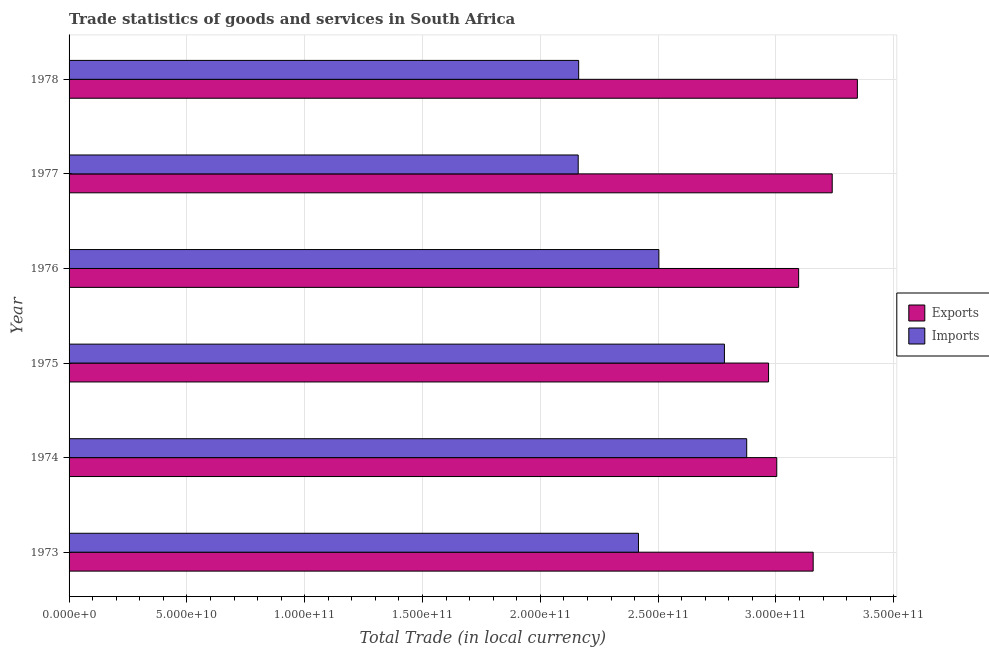How many groups of bars are there?
Offer a very short reply. 6. Are the number of bars per tick equal to the number of legend labels?
Provide a short and direct response. Yes. How many bars are there on the 3rd tick from the top?
Give a very brief answer. 2. How many bars are there on the 4th tick from the bottom?
Ensure brevity in your answer.  2. What is the label of the 4th group of bars from the top?
Make the answer very short. 1975. In how many cases, is the number of bars for a given year not equal to the number of legend labels?
Offer a very short reply. 0. What is the imports of goods and services in 1976?
Your answer should be very brief. 2.50e+11. Across all years, what is the maximum export of goods and services?
Your answer should be compact. 3.35e+11. Across all years, what is the minimum export of goods and services?
Offer a very short reply. 2.97e+11. In which year was the export of goods and services maximum?
Give a very brief answer. 1978. What is the total export of goods and services in the graph?
Ensure brevity in your answer.  1.88e+12. What is the difference between the imports of goods and services in 1975 and that in 1978?
Offer a very short reply. 6.19e+1. What is the difference between the imports of goods and services in 1974 and the export of goods and services in 1976?
Provide a short and direct response. -2.20e+1. What is the average imports of goods and services per year?
Your response must be concise. 2.48e+11. In the year 1975, what is the difference between the export of goods and services and imports of goods and services?
Provide a short and direct response. 1.87e+1. What is the ratio of the imports of goods and services in 1976 to that in 1978?
Your answer should be compact. 1.16. Is the difference between the export of goods and services in 1973 and 1978 greater than the difference between the imports of goods and services in 1973 and 1978?
Give a very brief answer. No. What is the difference between the highest and the second highest export of goods and services?
Provide a succinct answer. 1.07e+1. What is the difference between the highest and the lowest export of goods and services?
Keep it short and to the point. 3.77e+1. In how many years, is the export of goods and services greater than the average export of goods and services taken over all years?
Keep it short and to the point. 3. Is the sum of the export of goods and services in 1977 and 1978 greater than the maximum imports of goods and services across all years?
Ensure brevity in your answer.  Yes. What does the 1st bar from the top in 1974 represents?
Keep it short and to the point. Imports. What does the 2nd bar from the bottom in 1973 represents?
Make the answer very short. Imports. Are all the bars in the graph horizontal?
Offer a terse response. Yes. How many years are there in the graph?
Provide a succinct answer. 6. Are the values on the major ticks of X-axis written in scientific E-notation?
Offer a very short reply. Yes. Where does the legend appear in the graph?
Ensure brevity in your answer.  Center right. How are the legend labels stacked?
Give a very brief answer. Vertical. What is the title of the graph?
Your answer should be compact. Trade statistics of goods and services in South Africa. Does "Goods" appear as one of the legend labels in the graph?
Keep it short and to the point. No. What is the label or title of the X-axis?
Give a very brief answer. Total Trade (in local currency). What is the Total Trade (in local currency) in Exports in 1973?
Offer a very short reply. 3.16e+11. What is the Total Trade (in local currency) in Imports in 1973?
Your answer should be compact. 2.42e+11. What is the Total Trade (in local currency) in Exports in 1974?
Give a very brief answer. 3.00e+11. What is the Total Trade (in local currency) in Imports in 1974?
Ensure brevity in your answer.  2.88e+11. What is the Total Trade (in local currency) in Exports in 1975?
Give a very brief answer. 2.97e+11. What is the Total Trade (in local currency) in Imports in 1975?
Keep it short and to the point. 2.78e+11. What is the Total Trade (in local currency) of Exports in 1976?
Provide a short and direct response. 3.10e+11. What is the Total Trade (in local currency) of Imports in 1976?
Make the answer very short. 2.50e+11. What is the Total Trade (in local currency) in Exports in 1977?
Ensure brevity in your answer.  3.24e+11. What is the Total Trade (in local currency) in Imports in 1977?
Ensure brevity in your answer.  2.16e+11. What is the Total Trade (in local currency) of Exports in 1978?
Your answer should be compact. 3.35e+11. What is the Total Trade (in local currency) in Imports in 1978?
Ensure brevity in your answer.  2.16e+11. Across all years, what is the maximum Total Trade (in local currency) of Exports?
Keep it short and to the point. 3.35e+11. Across all years, what is the maximum Total Trade (in local currency) of Imports?
Your answer should be very brief. 2.88e+11. Across all years, what is the minimum Total Trade (in local currency) of Exports?
Ensure brevity in your answer.  2.97e+11. Across all years, what is the minimum Total Trade (in local currency) in Imports?
Offer a terse response. 2.16e+11. What is the total Total Trade (in local currency) in Exports in the graph?
Offer a very short reply. 1.88e+12. What is the total Total Trade (in local currency) in Imports in the graph?
Your response must be concise. 1.49e+12. What is the difference between the Total Trade (in local currency) in Exports in 1973 and that in 1974?
Ensure brevity in your answer.  1.54e+1. What is the difference between the Total Trade (in local currency) in Imports in 1973 and that in 1974?
Ensure brevity in your answer.  -4.59e+1. What is the difference between the Total Trade (in local currency) in Exports in 1973 and that in 1975?
Give a very brief answer. 1.89e+1. What is the difference between the Total Trade (in local currency) in Imports in 1973 and that in 1975?
Your answer should be very brief. -3.65e+1. What is the difference between the Total Trade (in local currency) in Exports in 1973 and that in 1976?
Provide a short and direct response. 6.17e+09. What is the difference between the Total Trade (in local currency) of Imports in 1973 and that in 1976?
Ensure brevity in your answer.  -8.66e+09. What is the difference between the Total Trade (in local currency) in Exports in 1973 and that in 1977?
Provide a succinct answer. -8.08e+09. What is the difference between the Total Trade (in local currency) of Imports in 1973 and that in 1977?
Keep it short and to the point. 2.56e+1. What is the difference between the Total Trade (in local currency) in Exports in 1973 and that in 1978?
Give a very brief answer. -1.88e+1. What is the difference between the Total Trade (in local currency) of Imports in 1973 and that in 1978?
Provide a short and direct response. 2.54e+1. What is the difference between the Total Trade (in local currency) in Exports in 1974 and that in 1975?
Your response must be concise. 3.48e+09. What is the difference between the Total Trade (in local currency) in Imports in 1974 and that in 1975?
Keep it short and to the point. 9.46e+09. What is the difference between the Total Trade (in local currency) of Exports in 1974 and that in 1976?
Keep it short and to the point. -9.28e+09. What is the difference between the Total Trade (in local currency) of Imports in 1974 and that in 1976?
Provide a succinct answer. 3.73e+1. What is the difference between the Total Trade (in local currency) in Exports in 1974 and that in 1977?
Provide a short and direct response. -2.35e+1. What is the difference between the Total Trade (in local currency) in Imports in 1974 and that in 1977?
Your answer should be compact. 7.15e+1. What is the difference between the Total Trade (in local currency) in Exports in 1974 and that in 1978?
Provide a short and direct response. -3.42e+1. What is the difference between the Total Trade (in local currency) of Imports in 1974 and that in 1978?
Offer a very short reply. 7.13e+1. What is the difference between the Total Trade (in local currency) of Exports in 1975 and that in 1976?
Make the answer very short. -1.28e+1. What is the difference between the Total Trade (in local currency) in Imports in 1975 and that in 1976?
Offer a very short reply. 2.78e+1. What is the difference between the Total Trade (in local currency) of Exports in 1975 and that in 1977?
Your response must be concise. -2.70e+1. What is the difference between the Total Trade (in local currency) in Imports in 1975 and that in 1977?
Your answer should be very brief. 6.21e+1. What is the difference between the Total Trade (in local currency) of Exports in 1975 and that in 1978?
Your answer should be very brief. -3.77e+1. What is the difference between the Total Trade (in local currency) of Imports in 1975 and that in 1978?
Provide a short and direct response. 6.19e+1. What is the difference between the Total Trade (in local currency) of Exports in 1976 and that in 1977?
Make the answer very short. -1.43e+1. What is the difference between the Total Trade (in local currency) of Imports in 1976 and that in 1977?
Your answer should be compact. 3.42e+1. What is the difference between the Total Trade (in local currency) of Exports in 1976 and that in 1978?
Your answer should be compact. -2.49e+1. What is the difference between the Total Trade (in local currency) in Imports in 1976 and that in 1978?
Your answer should be compact. 3.40e+1. What is the difference between the Total Trade (in local currency) of Exports in 1977 and that in 1978?
Your response must be concise. -1.07e+1. What is the difference between the Total Trade (in local currency) of Imports in 1977 and that in 1978?
Offer a very short reply. -1.96e+08. What is the difference between the Total Trade (in local currency) in Exports in 1973 and the Total Trade (in local currency) in Imports in 1974?
Make the answer very short. 2.82e+1. What is the difference between the Total Trade (in local currency) of Exports in 1973 and the Total Trade (in local currency) of Imports in 1975?
Keep it short and to the point. 3.77e+1. What is the difference between the Total Trade (in local currency) in Exports in 1973 and the Total Trade (in local currency) in Imports in 1976?
Your response must be concise. 6.55e+1. What is the difference between the Total Trade (in local currency) of Exports in 1973 and the Total Trade (in local currency) of Imports in 1977?
Provide a succinct answer. 9.97e+1. What is the difference between the Total Trade (in local currency) of Exports in 1973 and the Total Trade (in local currency) of Imports in 1978?
Your response must be concise. 9.95e+1. What is the difference between the Total Trade (in local currency) of Exports in 1974 and the Total Trade (in local currency) of Imports in 1975?
Your answer should be very brief. 2.22e+1. What is the difference between the Total Trade (in local currency) in Exports in 1974 and the Total Trade (in local currency) in Imports in 1976?
Ensure brevity in your answer.  5.00e+1. What is the difference between the Total Trade (in local currency) in Exports in 1974 and the Total Trade (in local currency) in Imports in 1977?
Provide a short and direct response. 8.43e+1. What is the difference between the Total Trade (in local currency) in Exports in 1974 and the Total Trade (in local currency) in Imports in 1978?
Provide a succinct answer. 8.41e+1. What is the difference between the Total Trade (in local currency) of Exports in 1975 and the Total Trade (in local currency) of Imports in 1976?
Offer a very short reply. 4.66e+1. What is the difference between the Total Trade (in local currency) in Exports in 1975 and the Total Trade (in local currency) in Imports in 1977?
Your response must be concise. 8.08e+1. What is the difference between the Total Trade (in local currency) of Exports in 1975 and the Total Trade (in local currency) of Imports in 1978?
Your answer should be very brief. 8.06e+1. What is the difference between the Total Trade (in local currency) of Exports in 1976 and the Total Trade (in local currency) of Imports in 1977?
Offer a terse response. 9.35e+1. What is the difference between the Total Trade (in local currency) in Exports in 1976 and the Total Trade (in local currency) in Imports in 1978?
Ensure brevity in your answer.  9.34e+1. What is the difference between the Total Trade (in local currency) of Exports in 1977 and the Total Trade (in local currency) of Imports in 1978?
Ensure brevity in your answer.  1.08e+11. What is the average Total Trade (in local currency) in Exports per year?
Your answer should be compact. 3.14e+11. What is the average Total Trade (in local currency) of Imports per year?
Give a very brief answer. 2.48e+11. In the year 1973, what is the difference between the Total Trade (in local currency) of Exports and Total Trade (in local currency) of Imports?
Your answer should be compact. 7.41e+1. In the year 1974, what is the difference between the Total Trade (in local currency) in Exports and Total Trade (in local currency) in Imports?
Your response must be concise. 1.28e+1. In the year 1975, what is the difference between the Total Trade (in local currency) of Exports and Total Trade (in local currency) of Imports?
Provide a short and direct response. 1.87e+1. In the year 1976, what is the difference between the Total Trade (in local currency) of Exports and Total Trade (in local currency) of Imports?
Provide a short and direct response. 5.93e+1. In the year 1977, what is the difference between the Total Trade (in local currency) of Exports and Total Trade (in local currency) of Imports?
Offer a very short reply. 1.08e+11. In the year 1978, what is the difference between the Total Trade (in local currency) of Exports and Total Trade (in local currency) of Imports?
Ensure brevity in your answer.  1.18e+11. What is the ratio of the Total Trade (in local currency) in Exports in 1973 to that in 1974?
Your answer should be compact. 1.05. What is the ratio of the Total Trade (in local currency) of Imports in 1973 to that in 1974?
Your answer should be compact. 0.84. What is the ratio of the Total Trade (in local currency) in Exports in 1973 to that in 1975?
Make the answer very short. 1.06. What is the ratio of the Total Trade (in local currency) of Imports in 1973 to that in 1975?
Provide a short and direct response. 0.87. What is the ratio of the Total Trade (in local currency) in Exports in 1973 to that in 1976?
Provide a succinct answer. 1.02. What is the ratio of the Total Trade (in local currency) of Imports in 1973 to that in 1976?
Your answer should be very brief. 0.97. What is the ratio of the Total Trade (in local currency) of Exports in 1973 to that in 1977?
Offer a very short reply. 0.97. What is the ratio of the Total Trade (in local currency) in Imports in 1973 to that in 1977?
Provide a short and direct response. 1.12. What is the ratio of the Total Trade (in local currency) in Exports in 1973 to that in 1978?
Your response must be concise. 0.94. What is the ratio of the Total Trade (in local currency) in Imports in 1973 to that in 1978?
Your answer should be compact. 1.12. What is the ratio of the Total Trade (in local currency) of Exports in 1974 to that in 1975?
Make the answer very short. 1.01. What is the ratio of the Total Trade (in local currency) of Imports in 1974 to that in 1975?
Offer a very short reply. 1.03. What is the ratio of the Total Trade (in local currency) of Exports in 1974 to that in 1976?
Your response must be concise. 0.97. What is the ratio of the Total Trade (in local currency) in Imports in 1974 to that in 1976?
Provide a succinct answer. 1.15. What is the ratio of the Total Trade (in local currency) of Exports in 1974 to that in 1977?
Your answer should be compact. 0.93. What is the ratio of the Total Trade (in local currency) of Imports in 1974 to that in 1977?
Keep it short and to the point. 1.33. What is the ratio of the Total Trade (in local currency) in Exports in 1974 to that in 1978?
Make the answer very short. 0.9. What is the ratio of the Total Trade (in local currency) of Imports in 1974 to that in 1978?
Ensure brevity in your answer.  1.33. What is the ratio of the Total Trade (in local currency) of Exports in 1975 to that in 1976?
Your answer should be very brief. 0.96. What is the ratio of the Total Trade (in local currency) in Exports in 1975 to that in 1977?
Offer a terse response. 0.92. What is the ratio of the Total Trade (in local currency) in Imports in 1975 to that in 1977?
Ensure brevity in your answer.  1.29. What is the ratio of the Total Trade (in local currency) in Exports in 1975 to that in 1978?
Ensure brevity in your answer.  0.89. What is the ratio of the Total Trade (in local currency) of Imports in 1975 to that in 1978?
Your answer should be very brief. 1.29. What is the ratio of the Total Trade (in local currency) in Exports in 1976 to that in 1977?
Keep it short and to the point. 0.96. What is the ratio of the Total Trade (in local currency) in Imports in 1976 to that in 1977?
Offer a very short reply. 1.16. What is the ratio of the Total Trade (in local currency) in Exports in 1976 to that in 1978?
Your answer should be very brief. 0.93. What is the ratio of the Total Trade (in local currency) of Imports in 1976 to that in 1978?
Keep it short and to the point. 1.16. What is the ratio of the Total Trade (in local currency) of Exports in 1977 to that in 1978?
Keep it short and to the point. 0.97. What is the ratio of the Total Trade (in local currency) in Imports in 1977 to that in 1978?
Make the answer very short. 1. What is the difference between the highest and the second highest Total Trade (in local currency) of Exports?
Your answer should be very brief. 1.07e+1. What is the difference between the highest and the second highest Total Trade (in local currency) of Imports?
Your response must be concise. 9.46e+09. What is the difference between the highest and the lowest Total Trade (in local currency) of Exports?
Keep it short and to the point. 3.77e+1. What is the difference between the highest and the lowest Total Trade (in local currency) of Imports?
Offer a very short reply. 7.15e+1. 